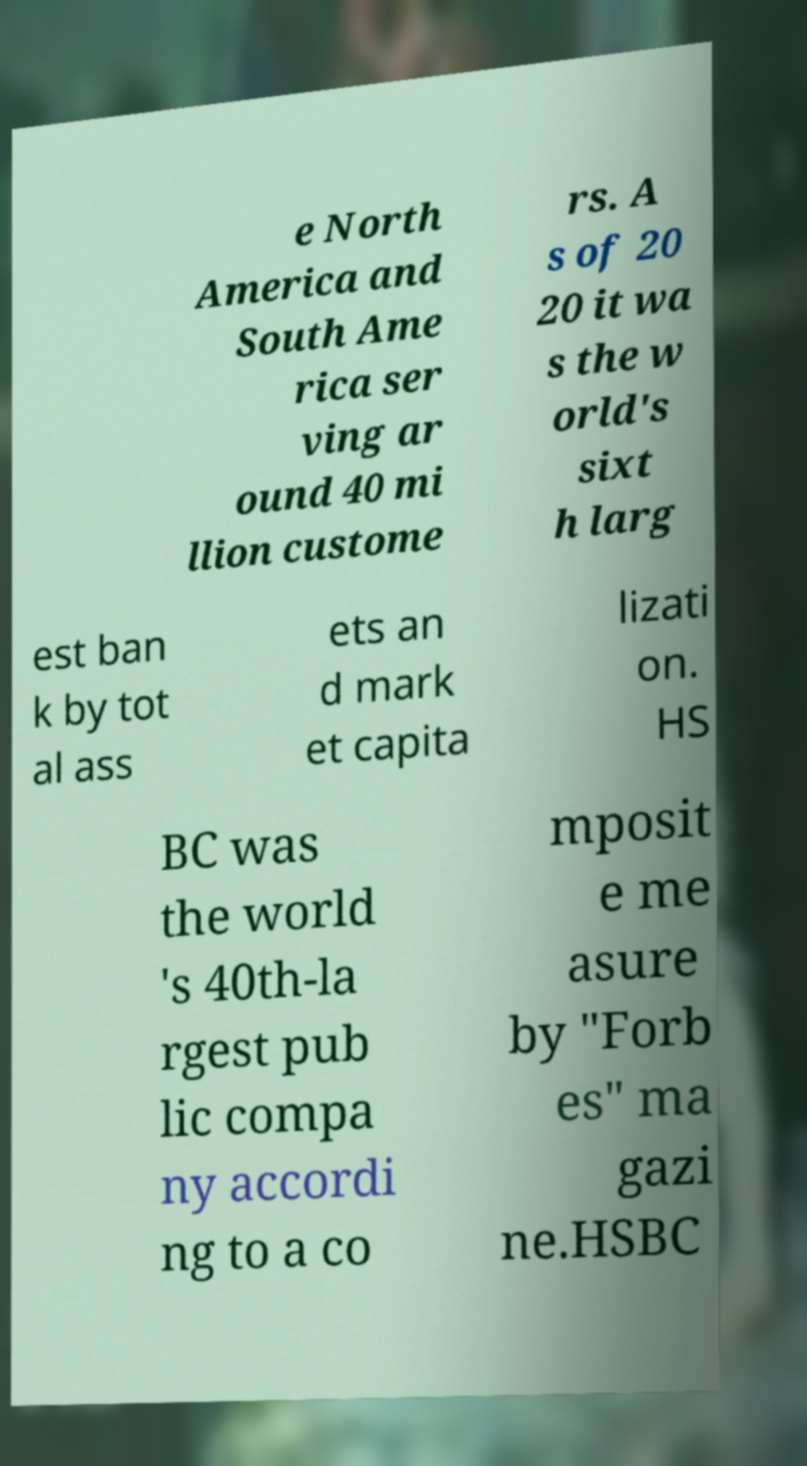Could you assist in decoding the text presented in this image and type it out clearly? e North America and South Ame rica ser ving ar ound 40 mi llion custome rs. A s of 20 20 it wa s the w orld's sixt h larg est ban k by tot al ass ets an d mark et capita lizati on. HS BC was the world 's 40th-la rgest pub lic compa ny accordi ng to a co mposit e me asure by "Forb es" ma gazi ne.HSBC 